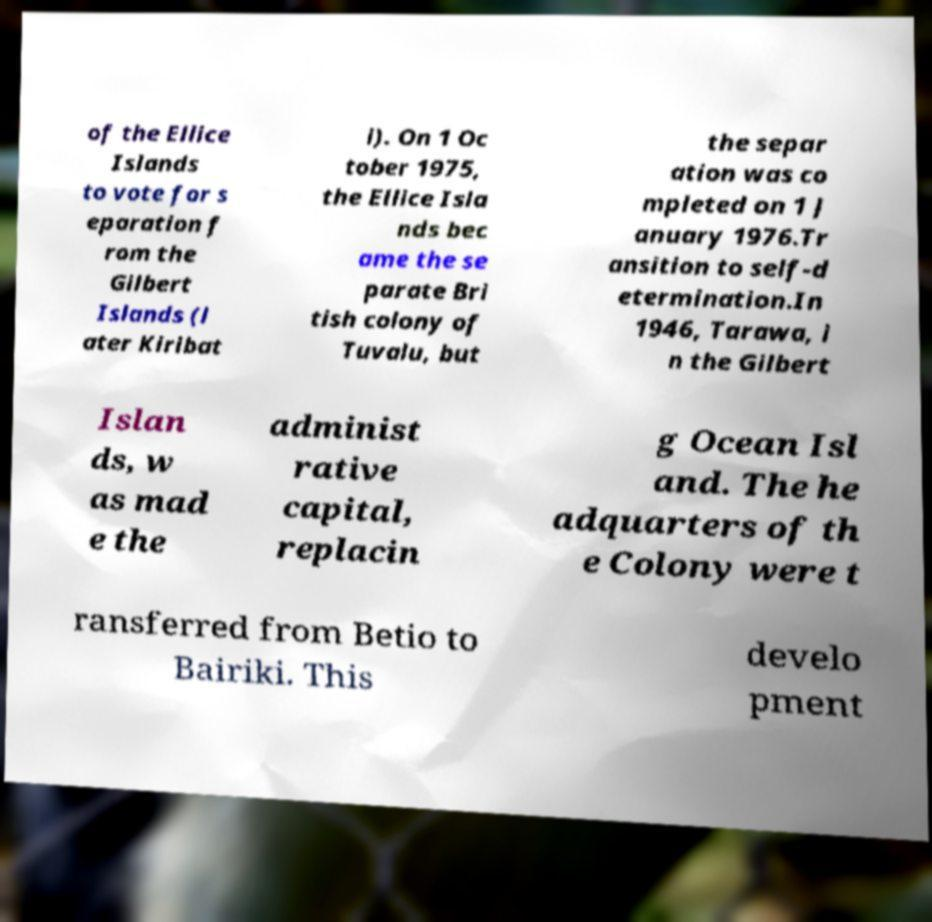Can you read and provide the text displayed in the image?This photo seems to have some interesting text. Can you extract and type it out for me? of the Ellice Islands to vote for s eparation f rom the Gilbert Islands (l ater Kiribat i). On 1 Oc tober 1975, the Ellice Isla nds bec ame the se parate Bri tish colony of Tuvalu, but the separ ation was co mpleted on 1 J anuary 1976.Tr ansition to self-d etermination.In 1946, Tarawa, i n the Gilbert Islan ds, w as mad e the administ rative capital, replacin g Ocean Isl and. The he adquarters of th e Colony were t ransferred from Betio to Bairiki. This develo pment 